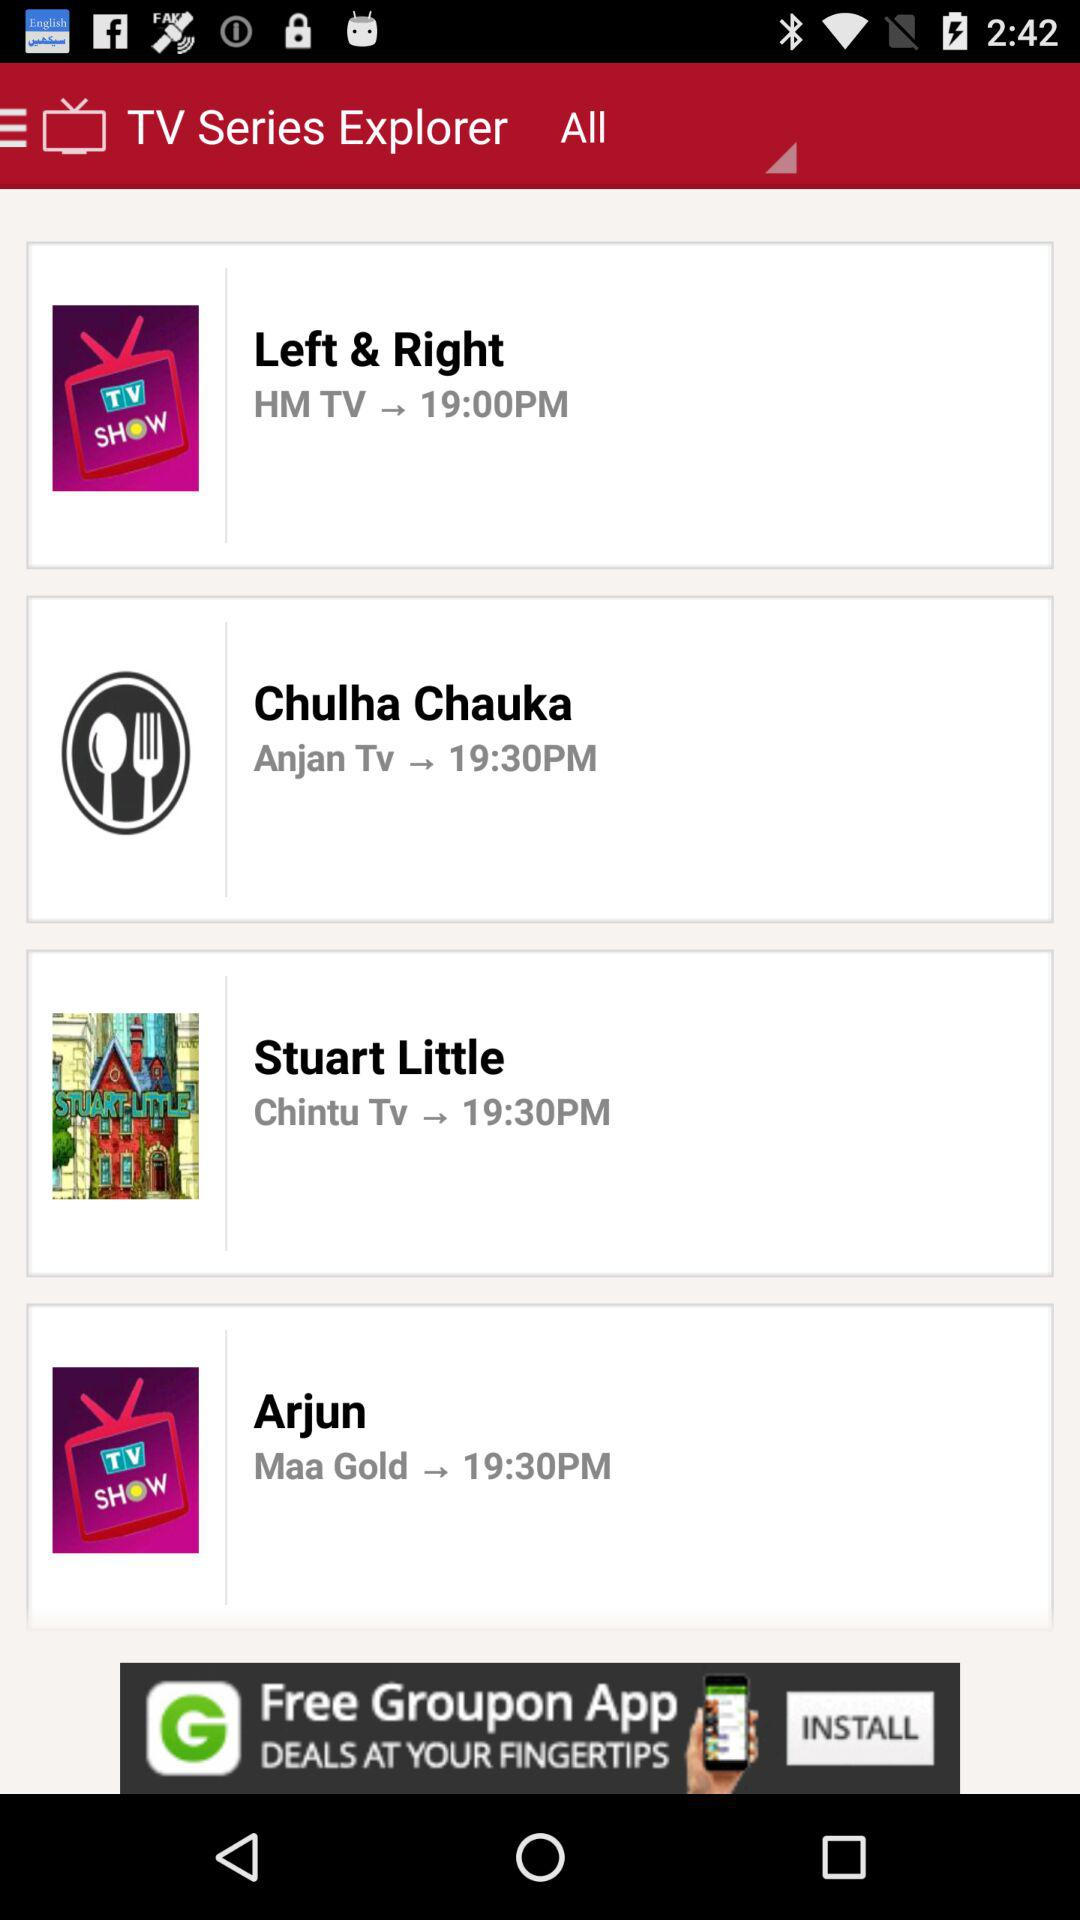What is the time of "Arjun"? The time of "Arjun" is 19:30. 